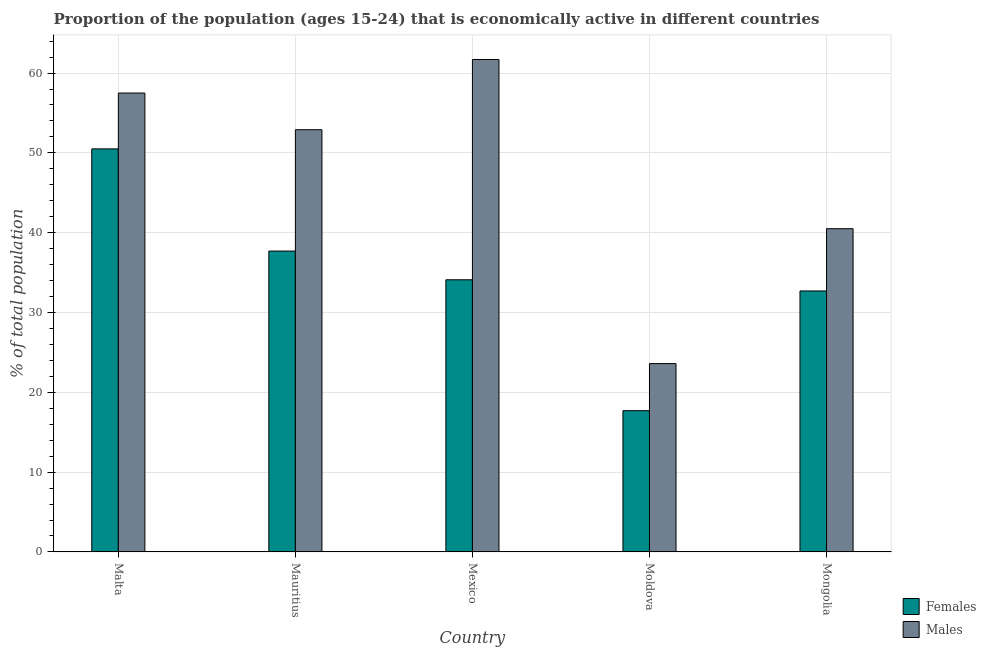How many groups of bars are there?
Offer a terse response. 5. What is the label of the 5th group of bars from the left?
Keep it short and to the point. Mongolia. In how many cases, is the number of bars for a given country not equal to the number of legend labels?
Provide a short and direct response. 0. What is the percentage of economically active male population in Mexico?
Ensure brevity in your answer.  61.7. Across all countries, what is the maximum percentage of economically active male population?
Provide a succinct answer. 61.7. Across all countries, what is the minimum percentage of economically active female population?
Provide a succinct answer. 17.7. In which country was the percentage of economically active female population maximum?
Ensure brevity in your answer.  Malta. In which country was the percentage of economically active female population minimum?
Offer a very short reply. Moldova. What is the total percentage of economically active male population in the graph?
Your answer should be compact. 236.2. What is the difference between the percentage of economically active female population in Malta and that in Moldova?
Provide a short and direct response. 32.8. What is the difference between the percentage of economically active female population in Mexico and the percentage of economically active male population in Malta?
Your answer should be compact. -23.4. What is the average percentage of economically active female population per country?
Ensure brevity in your answer.  34.54. What is the difference between the percentage of economically active male population and percentage of economically active female population in Mongolia?
Keep it short and to the point. 7.8. What is the ratio of the percentage of economically active male population in Mauritius to that in Mexico?
Your answer should be very brief. 0.86. Is the percentage of economically active female population in Mauritius less than that in Mongolia?
Offer a very short reply. No. What is the difference between the highest and the second highest percentage of economically active male population?
Offer a very short reply. 4.2. What is the difference between the highest and the lowest percentage of economically active male population?
Your response must be concise. 38.1. In how many countries, is the percentage of economically active female population greater than the average percentage of economically active female population taken over all countries?
Make the answer very short. 2. Is the sum of the percentage of economically active male population in Malta and Mexico greater than the maximum percentage of economically active female population across all countries?
Your response must be concise. Yes. What does the 2nd bar from the left in Malta represents?
Provide a short and direct response. Males. What does the 1st bar from the right in Malta represents?
Keep it short and to the point. Males. How many bars are there?
Offer a very short reply. 10. Are all the bars in the graph horizontal?
Ensure brevity in your answer.  No. How many countries are there in the graph?
Your answer should be very brief. 5. What is the difference between two consecutive major ticks on the Y-axis?
Ensure brevity in your answer.  10. How are the legend labels stacked?
Provide a succinct answer. Vertical. What is the title of the graph?
Ensure brevity in your answer.  Proportion of the population (ages 15-24) that is economically active in different countries. What is the label or title of the Y-axis?
Your answer should be compact. % of total population. What is the % of total population of Females in Malta?
Offer a terse response. 50.5. What is the % of total population of Males in Malta?
Your response must be concise. 57.5. What is the % of total population of Females in Mauritius?
Make the answer very short. 37.7. What is the % of total population in Males in Mauritius?
Keep it short and to the point. 52.9. What is the % of total population of Females in Mexico?
Provide a succinct answer. 34.1. What is the % of total population in Males in Mexico?
Your answer should be very brief. 61.7. What is the % of total population in Females in Moldova?
Offer a terse response. 17.7. What is the % of total population in Males in Moldova?
Provide a short and direct response. 23.6. What is the % of total population in Females in Mongolia?
Provide a short and direct response. 32.7. What is the % of total population of Males in Mongolia?
Make the answer very short. 40.5. Across all countries, what is the maximum % of total population in Females?
Offer a very short reply. 50.5. Across all countries, what is the maximum % of total population of Males?
Offer a terse response. 61.7. Across all countries, what is the minimum % of total population in Females?
Offer a terse response. 17.7. Across all countries, what is the minimum % of total population in Males?
Your answer should be compact. 23.6. What is the total % of total population in Females in the graph?
Your answer should be compact. 172.7. What is the total % of total population of Males in the graph?
Provide a short and direct response. 236.2. What is the difference between the % of total population of Females in Malta and that in Mauritius?
Give a very brief answer. 12.8. What is the difference between the % of total population in Females in Malta and that in Moldova?
Give a very brief answer. 32.8. What is the difference between the % of total population in Males in Malta and that in Moldova?
Your response must be concise. 33.9. What is the difference between the % of total population in Females in Malta and that in Mongolia?
Offer a very short reply. 17.8. What is the difference between the % of total population in Males in Malta and that in Mongolia?
Offer a terse response. 17. What is the difference between the % of total population in Males in Mauritius and that in Mexico?
Provide a succinct answer. -8.8. What is the difference between the % of total population in Males in Mauritius and that in Moldova?
Offer a terse response. 29.3. What is the difference between the % of total population of Males in Mexico and that in Moldova?
Ensure brevity in your answer.  38.1. What is the difference between the % of total population of Females in Mexico and that in Mongolia?
Your answer should be compact. 1.4. What is the difference between the % of total population of Males in Mexico and that in Mongolia?
Provide a short and direct response. 21.2. What is the difference between the % of total population in Females in Moldova and that in Mongolia?
Give a very brief answer. -15. What is the difference between the % of total population of Males in Moldova and that in Mongolia?
Provide a short and direct response. -16.9. What is the difference between the % of total population in Females in Malta and the % of total population in Males in Mauritius?
Ensure brevity in your answer.  -2.4. What is the difference between the % of total population in Females in Malta and the % of total population in Males in Mexico?
Offer a terse response. -11.2. What is the difference between the % of total population in Females in Malta and the % of total population in Males in Moldova?
Give a very brief answer. 26.9. What is the difference between the % of total population in Females in Mauritius and the % of total population in Males in Moldova?
Offer a terse response. 14.1. What is the difference between the % of total population in Females in Moldova and the % of total population in Males in Mongolia?
Offer a very short reply. -22.8. What is the average % of total population of Females per country?
Keep it short and to the point. 34.54. What is the average % of total population in Males per country?
Keep it short and to the point. 47.24. What is the difference between the % of total population in Females and % of total population in Males in Mauritius?
Ensure brevity in your answer.  -15.2. What is the difference between the % of total population of Females and % of total population of Males in Mexico?
Provide a succinct answer. -27.6. What is the difference between the % of total population in Females and % of total population in Males in Mongolia?
Provide a succinct answer. -7.8. What is the ratio of the % of total population of Females in Malta to that in Mauritius?
Your answer should be very brief. 1.34. What is the ratio of the % of total population of Males in Malta to that in Mauritius?
Provide a succinct answer. 1.09. What is the ratio of the % of total population in Females in Malta to that in Mexico?
Offer a very short reply. 1.48. What is the ratio of the % of total population in Males in Malta to that in Mexico?
Keep it short and to the point. 0.93. What is the ratio of the % of total population in Females in Malta to that in Moldova?
Offer a very short reply. 2.85. What is the ratio of the % of total population in Males in Malta to that in Moldova?
Offer a very short reply. 2.44. What is the ratio of the % of total population of Females in Malta to that in Mongolia?
Provide a short and direct response. 1.54. What is the ratio of the % of total population in Males in Malta to that in Mongolia?
Offer a very short reply. 1.42. What is the ratio of the % of total population of Females in Mauritius to that in Mexico?
Offer a terse response. 1.11. What is the ratio of the % of total population of Males in Mauritius to that in Mexico?
Provide a succinct answer. 0.86. What is the ratio of the % of total population in Females in Mauritius to that in Moldova?
Provide a short and direct response. 2.13. What is the ratio of the % of total population in Males in Mauritius to that in Moldova?
Provide a short and direct response. 2.24. What is the ratio of the % of total population of Females in Mauritius to that in Mongolia?
Your response must be concise. 1.15. What is the ratio of the % of total population of Males in Mauritius to that in Mongolia?
Make the answer very short. 1.31. What is the ratio of the % of total population in Females in Mexico to that in Moldova?
Your response must be concise. 1.93. What is the ratio of the % of total population of Males in Mexico to that in Moldova?
Make the answer very short. 2.61. What is the ratio of the % of total population of Females in Mexico to that in Mongolia?
Keep it short and to the point. 1.04. What is the ratio of the % of total population in Males in Mexico to that in Mongolia?
Give a very brief answer. 1.52. What is the ratio of the % of total population of Females in Moldova to that in Mongolia?
Your answer should be very brief. 0.54. What is the ratio of the % of total population in Males in Moldova to that in Mongolia?
Give a very brief answer. 0.58. What is the difference between the highest and the second highest % of total population of Females?
Ensure brevity in your answer.  12.8. What is the difference between the highest and the lowest % of total population of Females?
Give a very brief answer. 32.8. What is the difference between the highest and the lowest % of total population in Males?
Ensure brevity in your answer.  38.1. 